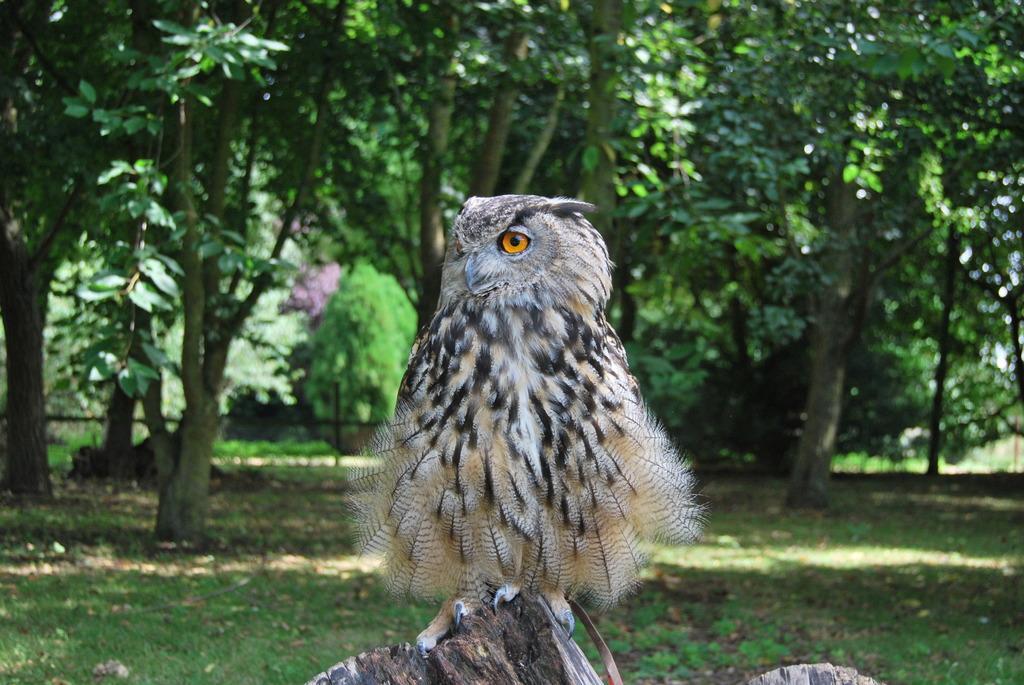Can you describe this image briefly? In this picture I can see an owl standing on the wood, and in the background there are plants and trees. 